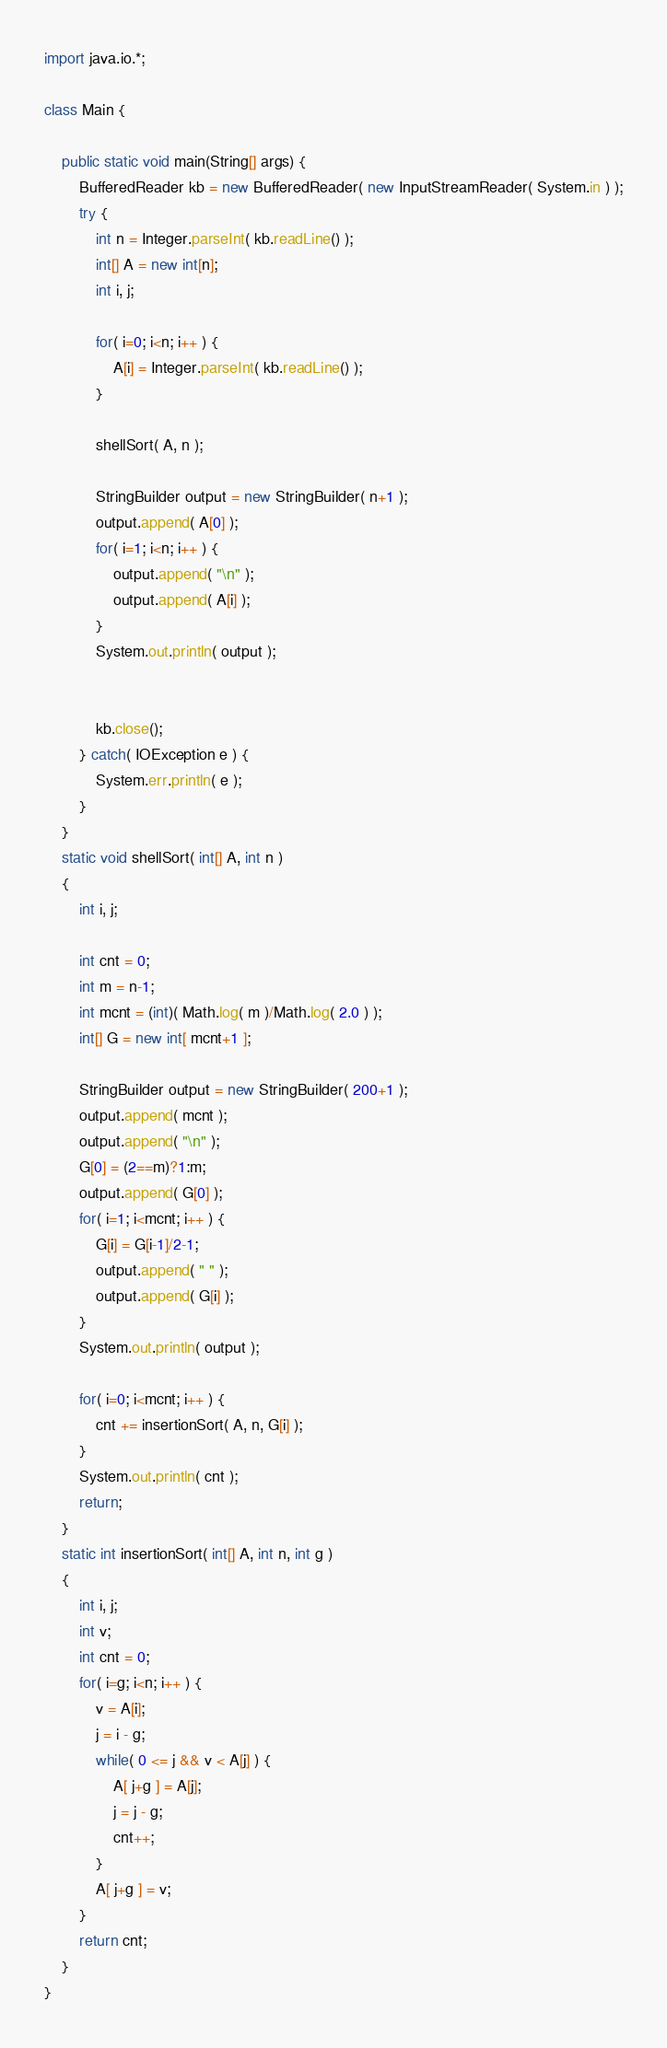Convert code to text. <code><loc_0><loc_0><loc_500><loc_500><_Java_>import java.io.*;

class Main {
	
    public static void main(String[] args) {
        BufferedReader kb = new BufferedReader( new InputStreamReader( System.in ) );
        try {
            int n = Integer.parseInt( kb.readLine() );
			int[] A = new int[n];
            int i, j;
                        
            for( i=0; i<n; i++ ) {
            	A[i] = Integer.parseInt( kb.readLine() );
            }
			
			shellSort( A, n );
			
			StringBuilder output = new StringBuilder( n+1 );	
			output.append( A[0] );
            for( i=1; i<n; i++ ) {
            	output.append( "\n" );
               	output.append( A[i] );
            }
            System.out.println( output );

	 
            kb.close();
        } catch( IOException e ) {
            System.err.println( e );
        }        
    }
    static void shellSort( int[] A, int n ) 
    {
        int i, j;
        
        int cnt = 0;
        int m = n-1;
        int mcnt = (int)( Math.log( m )/Math.log( 2.0 ) );
        int[] G = new int[ mcnt+1 ];

		StringBuilder output = new StringBuilder( 200+1 );
        output.append( mcnt );
        output.append( "\n" );
        G[0] = (2==m)?1:m;
        output.append( G[0] );
        for( i=1; i<mcnt; i++ ) {
        	G[i] = G[i-1]/2-1;
	        output.append( " " );
	        output.append( G[i] );
        }
        System.out.println( output );
        
        for( i=0; i<mcnt; i++ ) {
        	cnt += insertionSort( A, n, G[i] );
        }
        System.out.println( cnt );
        return;
    }    
    static int insertionSort( int[] A, int n, int g ) 
    {
    	int i, j;
    	int v;
		int cnt = 0;
   		for( i=g; i<n; i++ ) {
   			v = A[i];
   			j = i - g;
   			while( 0 <= j && v < A[j] ) {
   				A[ j+g ] = A[j];
   				j = j - g;
   				cnt++;
   			}
   			A[ j+g ] = v;
   		}
   		return cnt;
    }
}</code> 